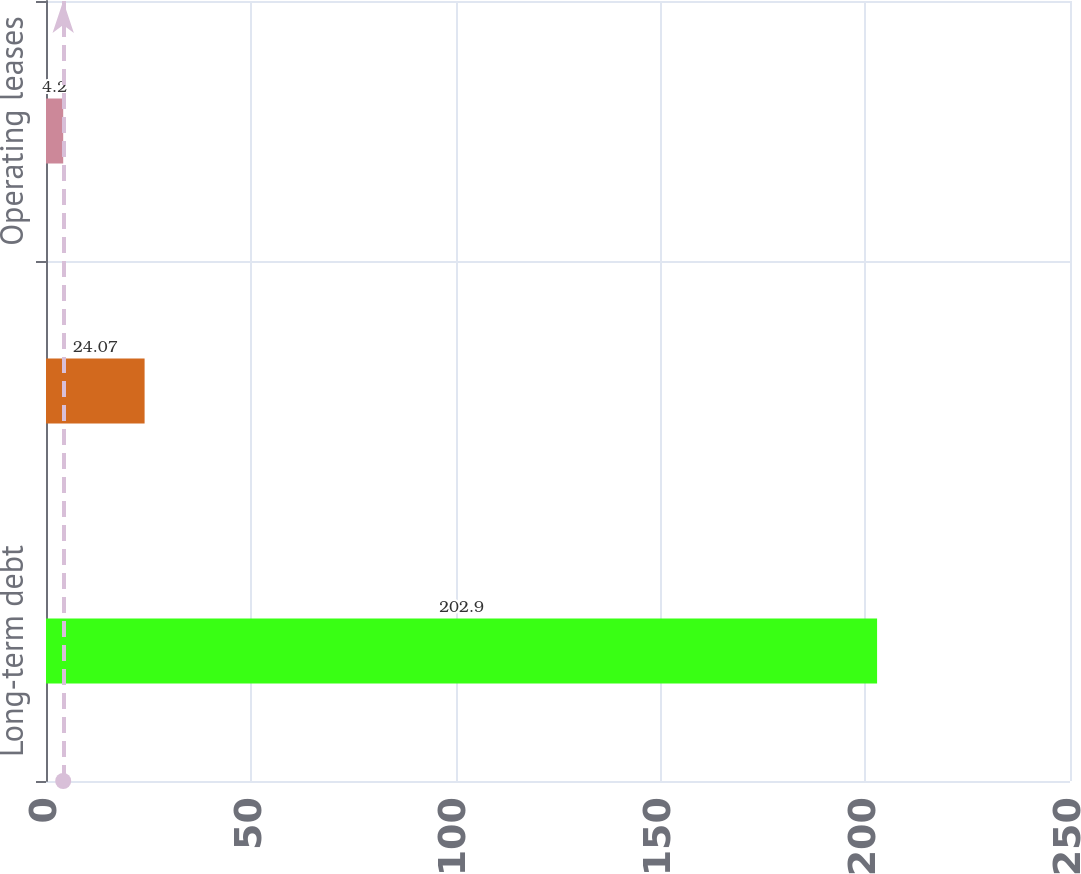<chart> <loc_0><loc_0><loc_500><loc_500><bar_chart><fcel>Long-term debt<fcel>Fixed rate interest<fcel>Operating leases<nl><fcel>202.9<fcel>24.07<fcel>4.2<nl></chart> 